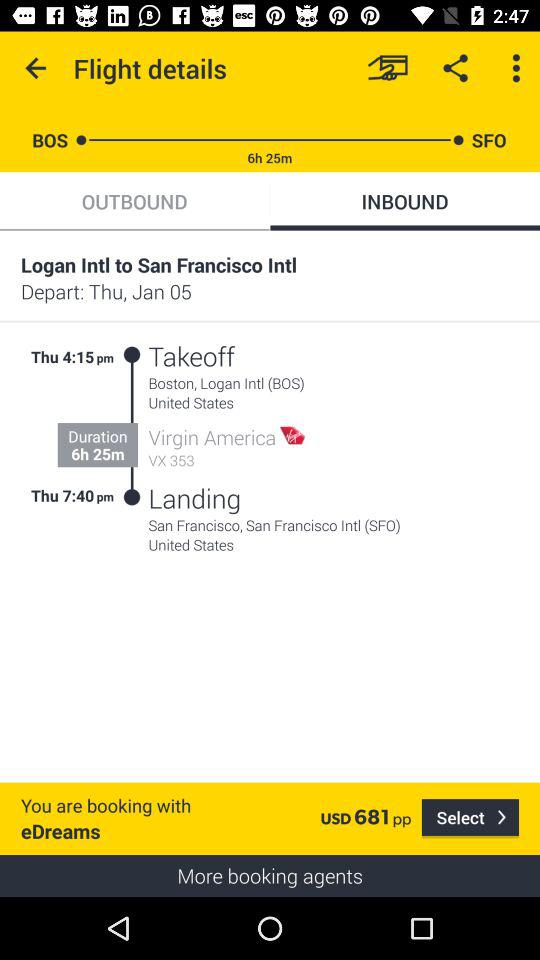What is the price of the flight?
Answer the question using a single word or phrase. USD 681 pp 